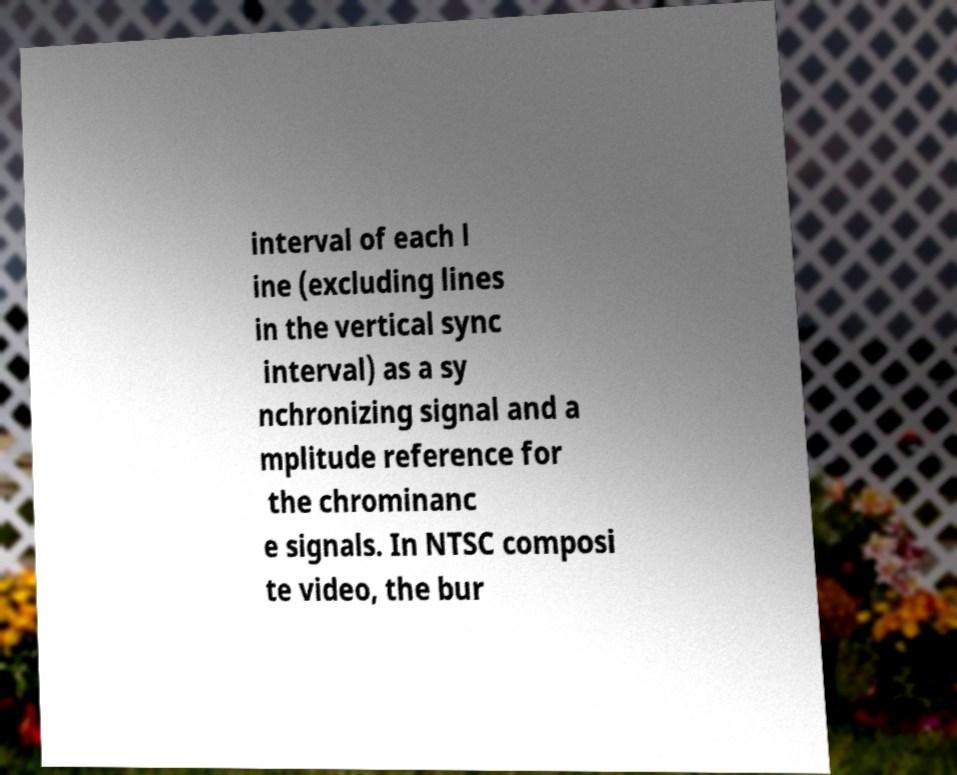Could you extract and type out the text from this image? interval of each l ine (excluding lines in the vertical sync interval) as a sy nchronizing signal and a mplitude reference for the chrominanc e signals. In NTSC composi te video, the bur 